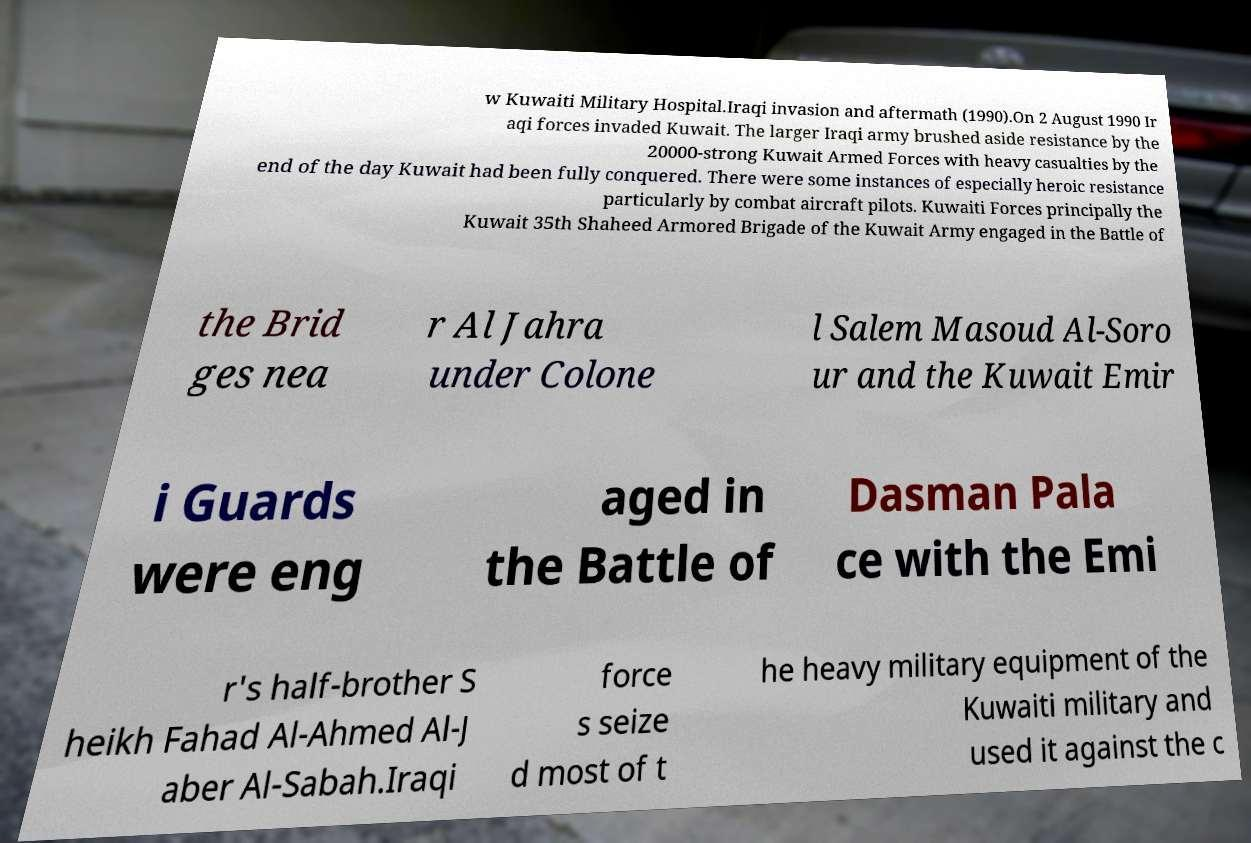Could you assist in decoding the text presented in this image and type it out clearly? w Kuwaiti Military Hospital.Iraqi invasion and aftermath (1990).On 2 August 1990 Ir aqi forces invaded Kuwait. The larger Iraqi army brushed aside resistance by the 20000-strong Kuwait Armed Forces with heavy casualties by the end of the day Kuwait had been fully conquered. There were some instances of especially heroic resistance particularly by combat aircraft pilots. Kuwaiti Forces principally the Kuwait 35th Shaheed Armored Brigade of the Kuwait Army engaged in the Battle of the Brid ges nea r Al Jahra under Colone l Salem Masoud Al-Soro ur and the Kuwait Emir i Guards were eng aged in the Battle of Dasman Pala ce with the Emi r's half-brother S heikh Fahad Al-Ahmed Al-J aber Al-Sabah.Iraqi force s seize d most of t he heavy military equipment of the Kuwaiti military and used it against the c 